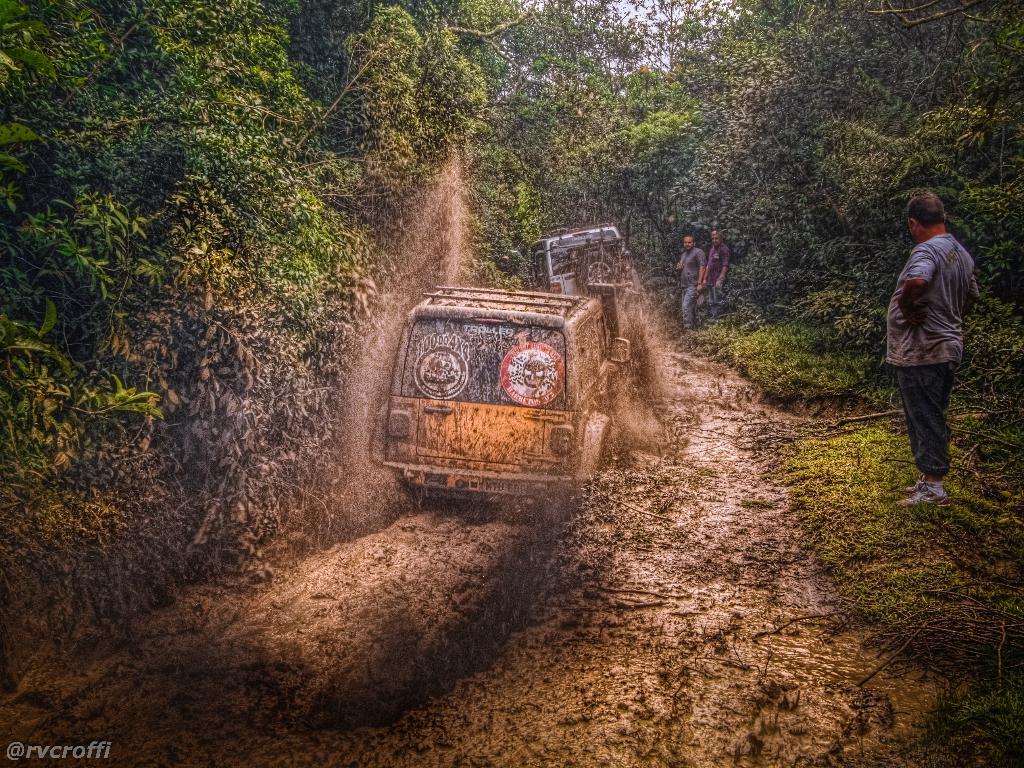Describe this image in one or two sentences. In the middle of this image there is a vehicle on the ground. On the right side three men are standing. In the background there are many trees. 